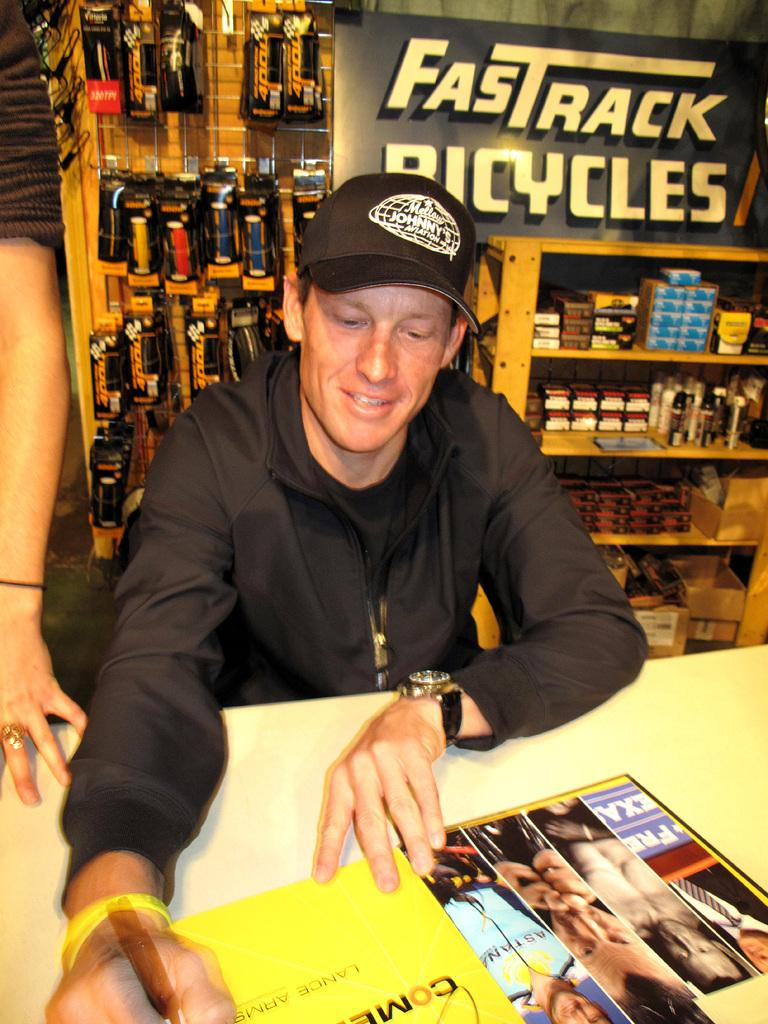<image>
Render a clear and concise summary of the photo. A Fastrack Bicycles sign behind a seated man. 